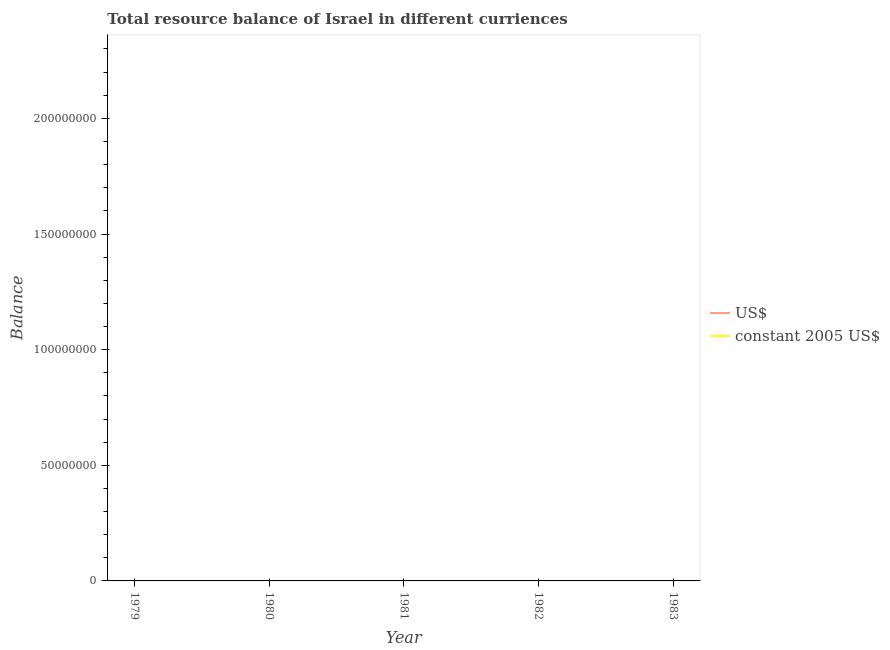How many different coloured lines are there?
Provide a succinct answer. 0. Is the number of lines equal to the number of legend labels?
Your answer should be very brief. No. Across all years, what is the minimum resource balance in us$?
Your answer should be very brief. 0. What is the total resource balance in constant us$ in the graph?
Provide a short and direct response. 0. What is the difference between the resource balance in constant us$ in 1981 and the resource balance in us$ in 1982?
Your response must be concise. 0. In how many years, is the resource balance in constant us$ greater than the average resource balance in constant us$ taken over all years?
Your answer should be compact. 0. Does the resource balance in us$ monotonically increase over the years?
Provide a short and direct response. No. Is the resource balance in constant us$ strictly less than the resource balance in us$ over the years?
Make the answer very short. No. How many lines are there?
Provide a short and direct response. 0. How many years are there in the graph?
Give a very brief answer. 5. What is the difference between two consecutive major ticks on the Y-axis?
Your answer should be very brief. 5.00e+07. Does the graph contain any zero values?
Provide a short and direct response. Yes. Does the graph contain grids?
Give a very brief answer. No. What is the title of the graph?
Offer a terse response. Total resource balance of Israel in different curriences. Does "International Visitors" appear as one of the legend labels in the graph?
Give a very brief answer. No. What is the label or title of the Y-axis?
Make the answer very short. Balance. What is the Balance of US$ in 1979?
Ensure brevity in your answer.  0. What is the Balance of constant 2005 US$ in 1981?
Make the answer very short. 0. What is the Balance in US$ in 1983?
Offer a terse response. 0. What is the Balance in constant 2005 US$ in 1983?
Give a very brief answer. 0. What is the total Balance in US$ in the graph?
Your response must be concise. 0. What is the average Balance in US$ per year?
Give a very brief answer. 0. 